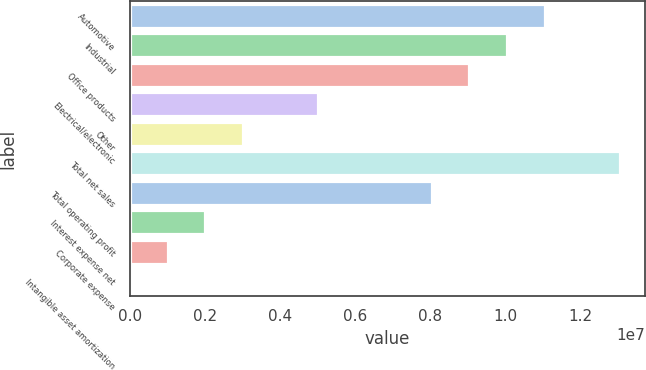<chart> <loc_0><loc_0><loc_500><loc_500><bar_chart><fcel>Automotive<fcel>Industrial<fcel>Office products<fcel>Electrical/electronic<fcel>Other<fcel>Total net sales<fcel>Total operating profit<fcel>Interest expense net<fcel>Corporate expense<fcel>Intangible asset amortization<nl><fcel>1.10629e+07<fcel>1.00575e+07<fcel>9.05213e+06<fcel>5.03058e+06<fcel>3.0198e+06<fcel>1.30737e+07<fcel>8.04674e+06<fcel>2.01442e+06<fcel>1.00903e+06<fcel>3644<nl></chart> 